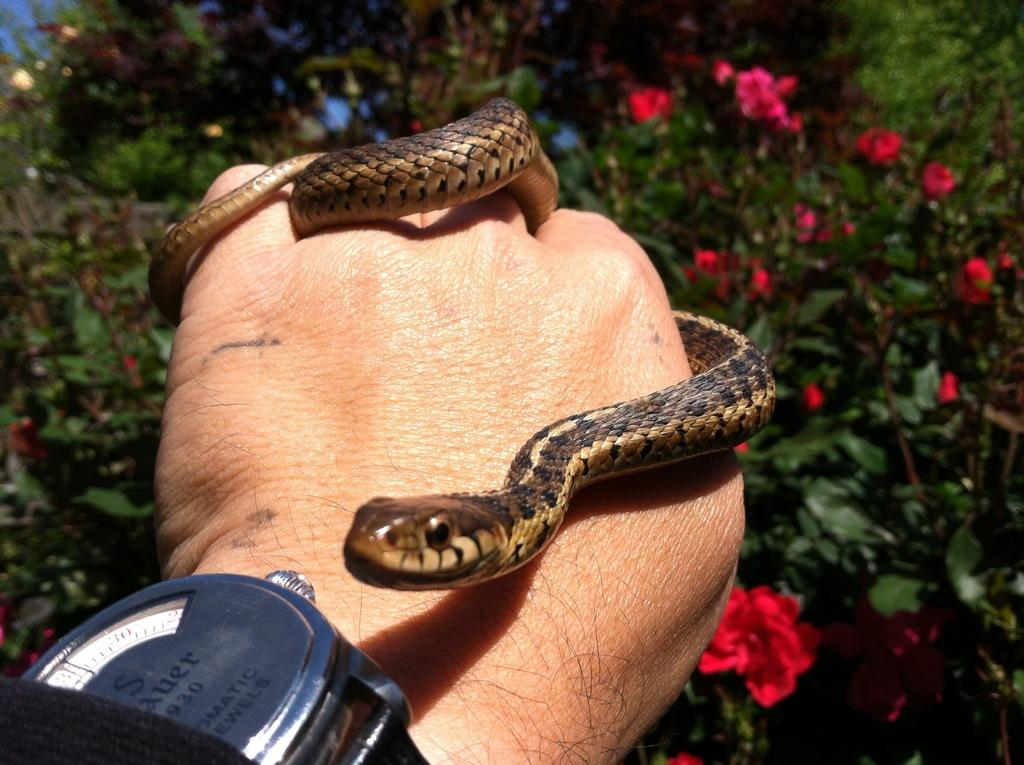What type of living organisms can be seen in the image? Plants and flowers are visible in the image. What else is present in the image besides plants and flowers? There is a human hand wearing a watch in the image. What is the hand holding in the image? The hand is holding a snake in the image. What type of brake can be seen in the image? There is no brake present in the image. Can you describe the bed in the image? There is no bed present in the image. 